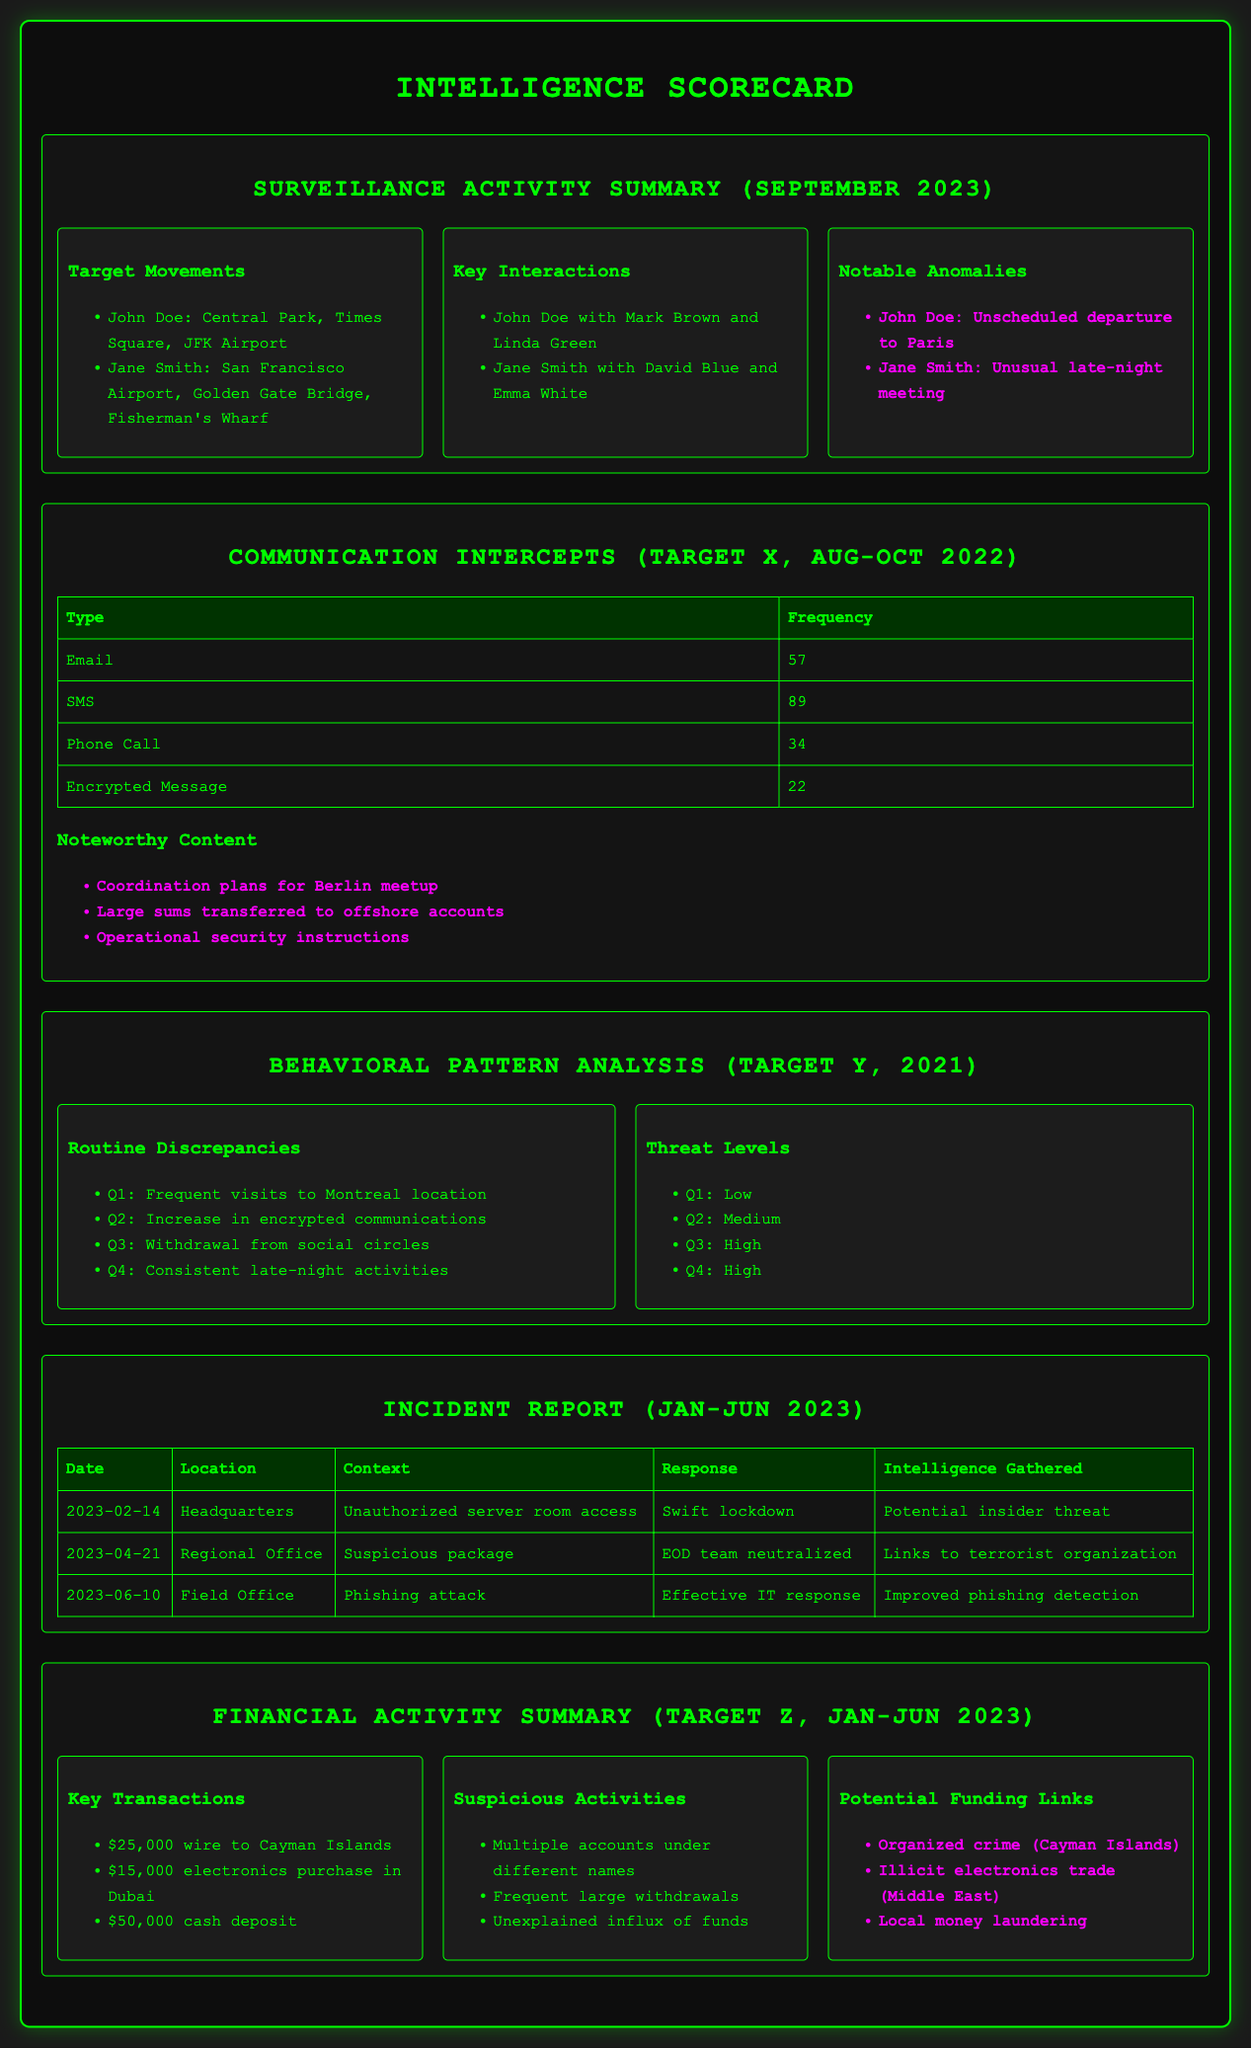What are the notable anomalies for John Doe? The document lists notable anomalies specifically for John Doe which includes his unscheduled departure to Paris.
Answer: Unscheduled departure to Paris How many emails were intercepted for Target X? The communication intercepts section provides the frequency of message types for Target X, which states 57 emails were intercepted.
Answer: 57 What was the response to the unauthorized server room access incident? The incident report outlines the response to incidents, stating that the response to the unauthorized server room access was a swift lockdown.
Answer: Swift lockdown In which quarter did Target Y have a low threat level? The behavioral pattern analysis highlights the change in threat levels for Target Y, specifying that a low threat level was recorded in Q1.
Answer: Q1 What transaction amount was wired to the Cayman Islands? The financial activity summary details the key transactions for Target Z, indicating a wire transfer amount of $25,000 to the Cayman Islands.
Answer: $25,000 What significant event occurred on February 14, 2023? The incident report outlines recorded incidents, mentioning that unauthorized server room access occurred on February 14, 2023.
Answer: Unauthorized server room access What type of messages had the highest frequency for Target X? The communication intercepts show that SMS messages had the highest frequency, totaling 89.
Answer: SMS Which quarter showed an increase in encrypted communications for Target Y? The behavioral pattern analysis highlights that there was an increase in encrypted communications for Target Y in Q2.
Answer: Q2 What was a key interaction for Jane Smith? The surveillance activity summary lists a key interaction for Jane Smith with David Blue and Emma White.
Answer: David Blue and Emma White 